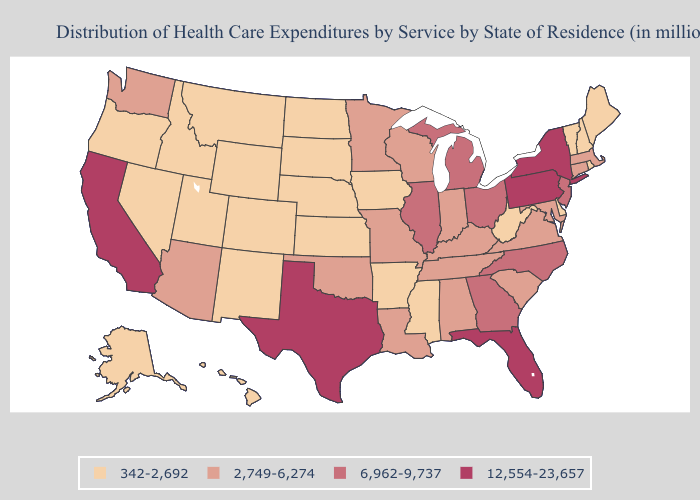Does the map have missing data?
Give a very brief answer. No. Name the states that have a value in the range 6,962-9,737?
Give a very brief answer. Georgia, Illinois, Michigan, New Jersey, North Carolina, Ohio. Does Illinois have the lowest value in the MidWest?
Write a very short answer. No. Does the map have missing data?
Write a very short answer. No. Is the legend a continuous bar?
Give a very brief answer. No. Name the states that have a value in the range 12,554-23,657?
Short answer required. California, Florida, New York, Pennsylvania, Texas. Which states have the lowest value in the USA?
Write a very short answer. Alaska, Arkansas, Colorado, Delaware, Hawaii, Idaho, Iowa, Kansas, Maine, Mississippi, Montana, Nebraska, Nevada, New Hampshire, New Mexico, North Dakota, Oregon, Rhode Island, South Dakota, Utah, Vermont, West Virginia, Wyoming. Which states have the highest value in the USA?
Answer briefly. California, Florida, New York, Pennsylvania, Texas. Does Michigan have the lowest value in the USA?
Write a very short answer. No. What is the value of Arizona?
Short answer required. 2,749-6,274. Name the states that have a value in the range 12,554-23,657?
Answer briefly. California, Florida, New York, Pennsylvania, Texas. Name the states that have a value in the range 12,554-23,657?
Write a very short answer. California, Florida, New York, Pennsylvania, Texas. What is the value of Pennsylvania?
Keep it brief. 12,554-23,657. Among the states that border Missouri , which have the highest value?
Short answer required. Illinois. Name the states that have a value in the range 6,962-9,737?
Be succinct. Georgia, Illinois, Michigan, New Jersey, North Carolina, Ohio. 